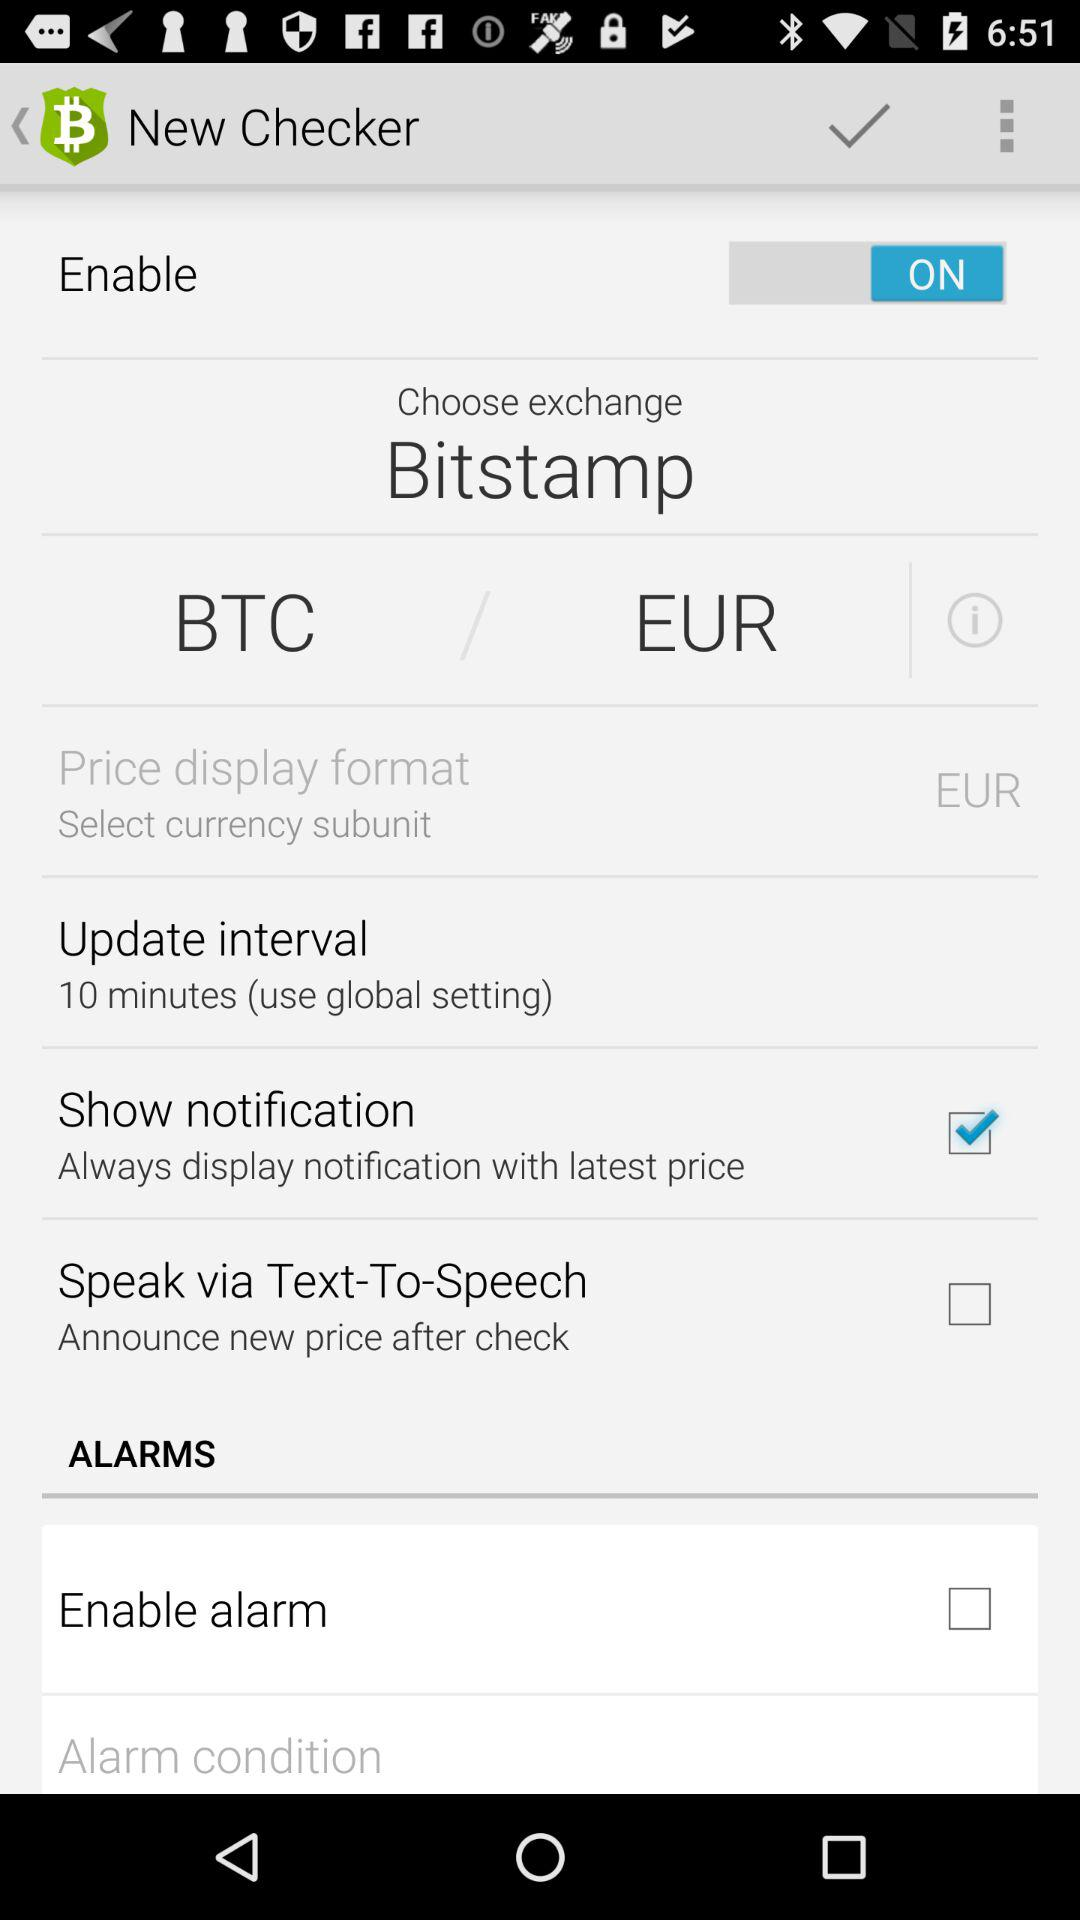What is the update interval duration? The update interval duration is 10 minutes. 